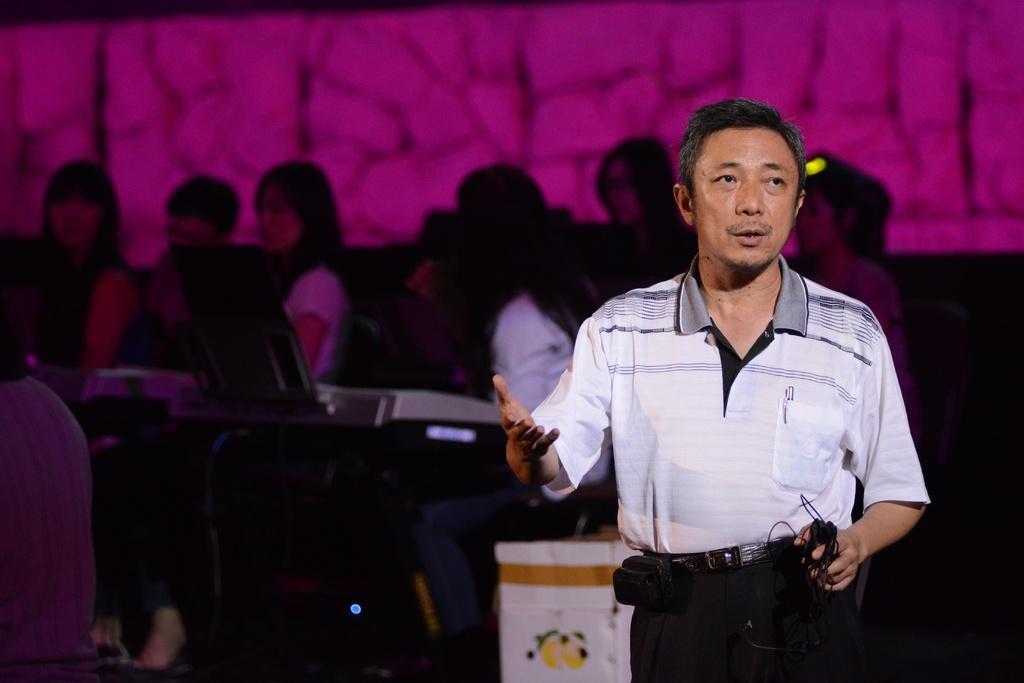Can you describe this image briefly? In this image there is a man standing, in the background there are people sitting on chairs, in front of them there are musical instruments. 